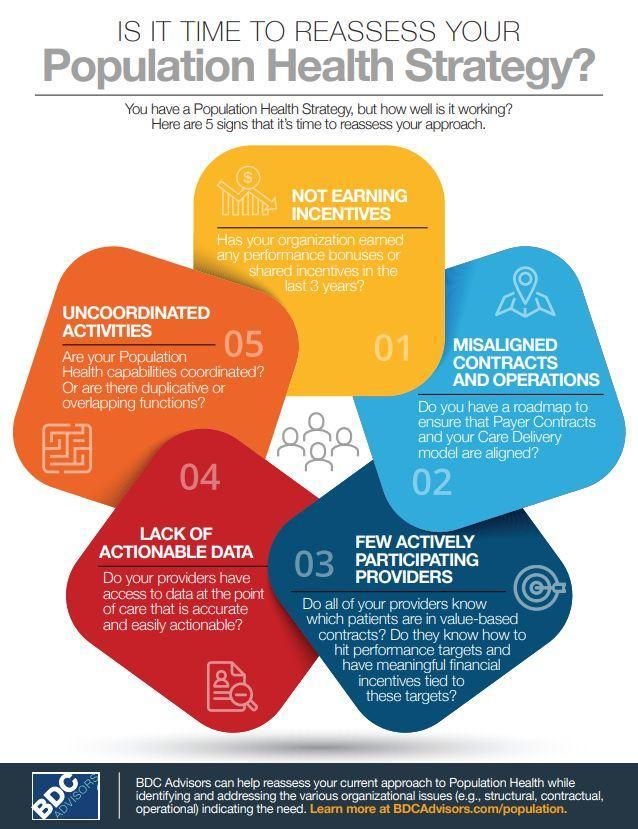What is reason 1 for reassesing your population health strategy
Answer the question with a short phrase. not earning incentives What is the reason stated on the red card Lack of actionable data What could be the reason for reassesing your population health strategy if there is duplicative or overlapping functions uncoordinated activities 